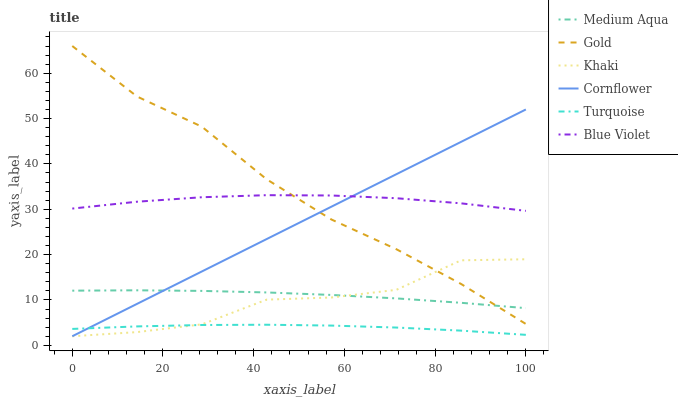Does Turquoise have the minimum area under the curve?
Answer yes or no. Yes. Does Gold have the maximum area under the curve?
Answer yes or no. Yes. Does Khaki have the minimum area under the curve?
Answer yes or no. No. Does Khaki have the maximum area under the curve?
Answer yes or no. No. Is Cornflower the smoothest?
Answer yes or no. Yes. Is Khaki the roughest?
Answer yes or no. Yes. Is Turquoise the smoothest?
Answer yes or no. No. Is Turquoise the roughest?
Answer yes or no. No. Does Cornflower have the lowest value?
Answer yes or no. Yes. Does Turquoise have the lowest value?
Answer yes or no. No. Does Gold have the highest value?
Answer yes or no. Yes. Does Khaki have the highest value?
Answer yes or no. No. Is Turquoise less than Gold?
Answer yes or no. Yes. Is Medium Aqua greater than Turquoise?
Answer yes or no. Yes. Does Turquoise intersect Cornflower?
Answer yes or no. Yes. Is Turquoise less than Cornflower?
Answer yes or no. No. Is Turquoise greater than Cornflower?
Answer yes or no. No. Does Turquoise intersect Gold?
Answer yes or no. No. 